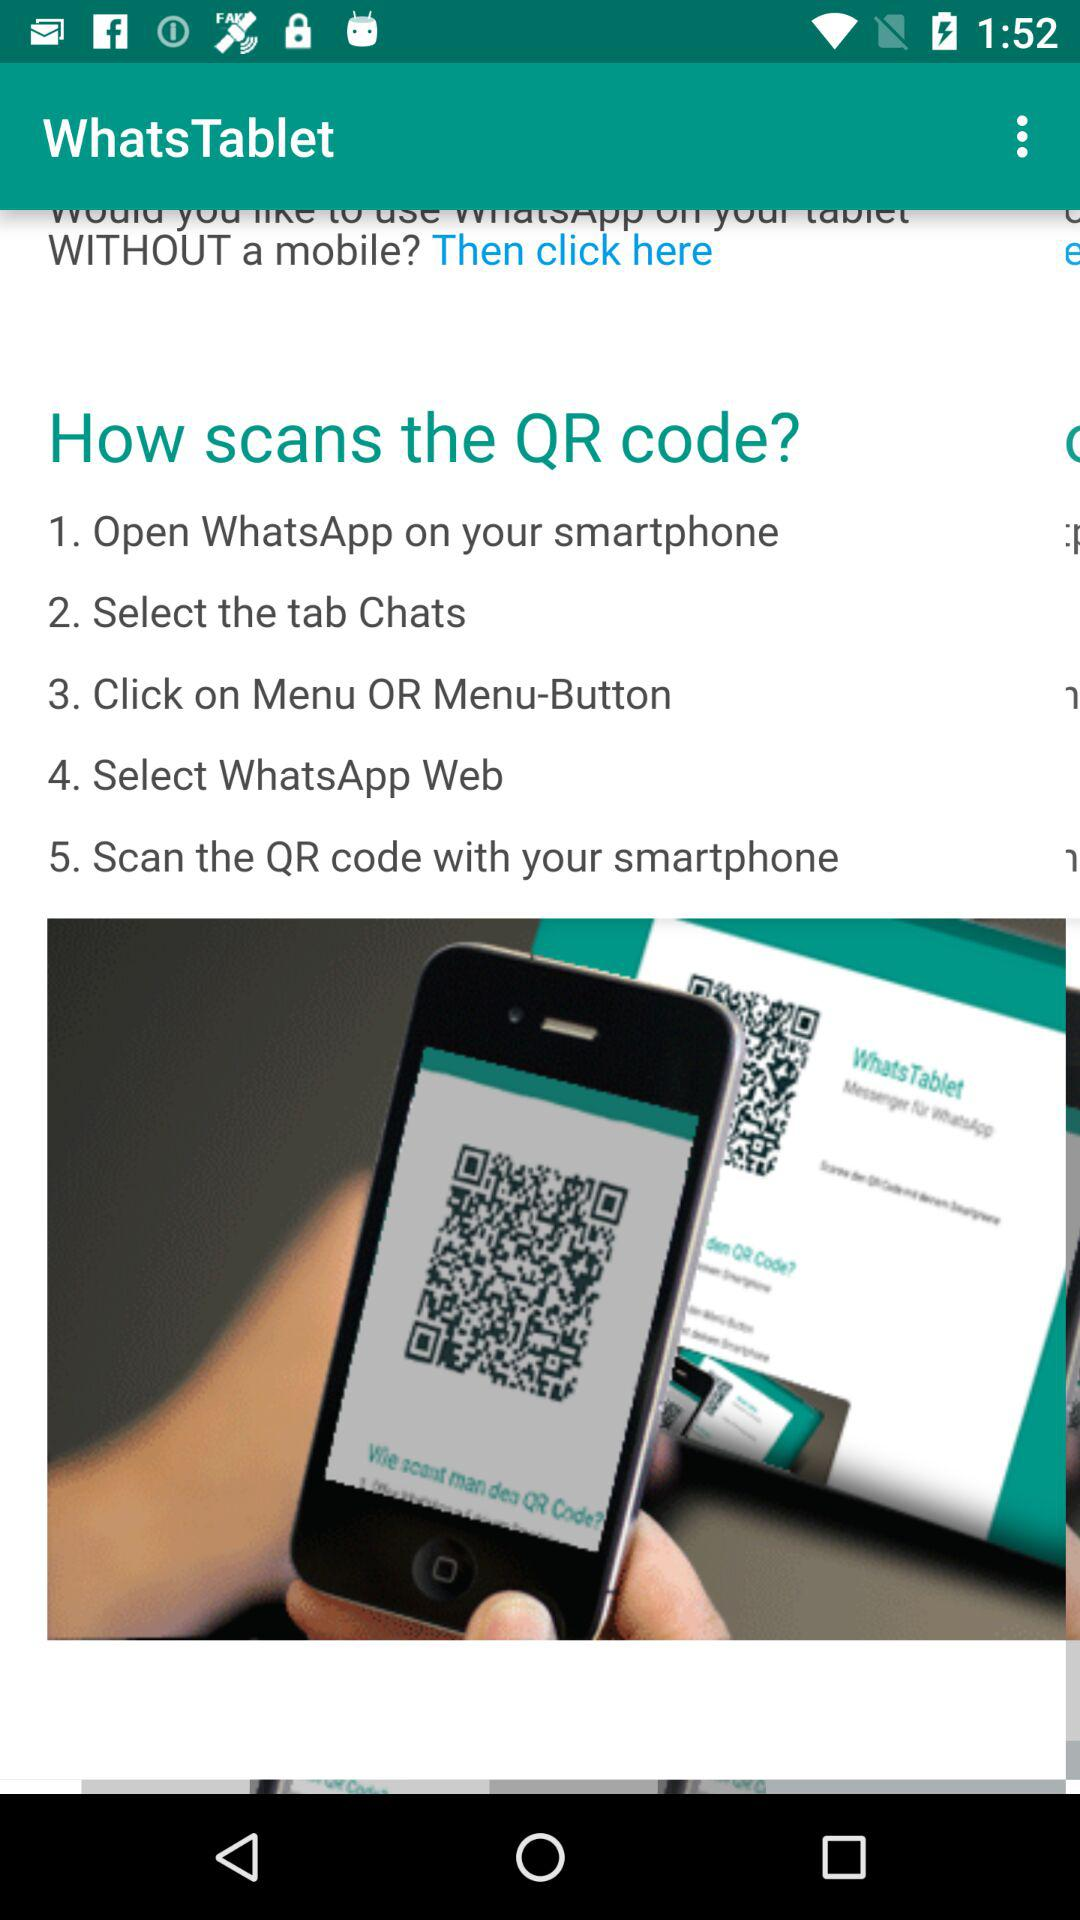What is the application name? The application name is "WhatsTablet". 